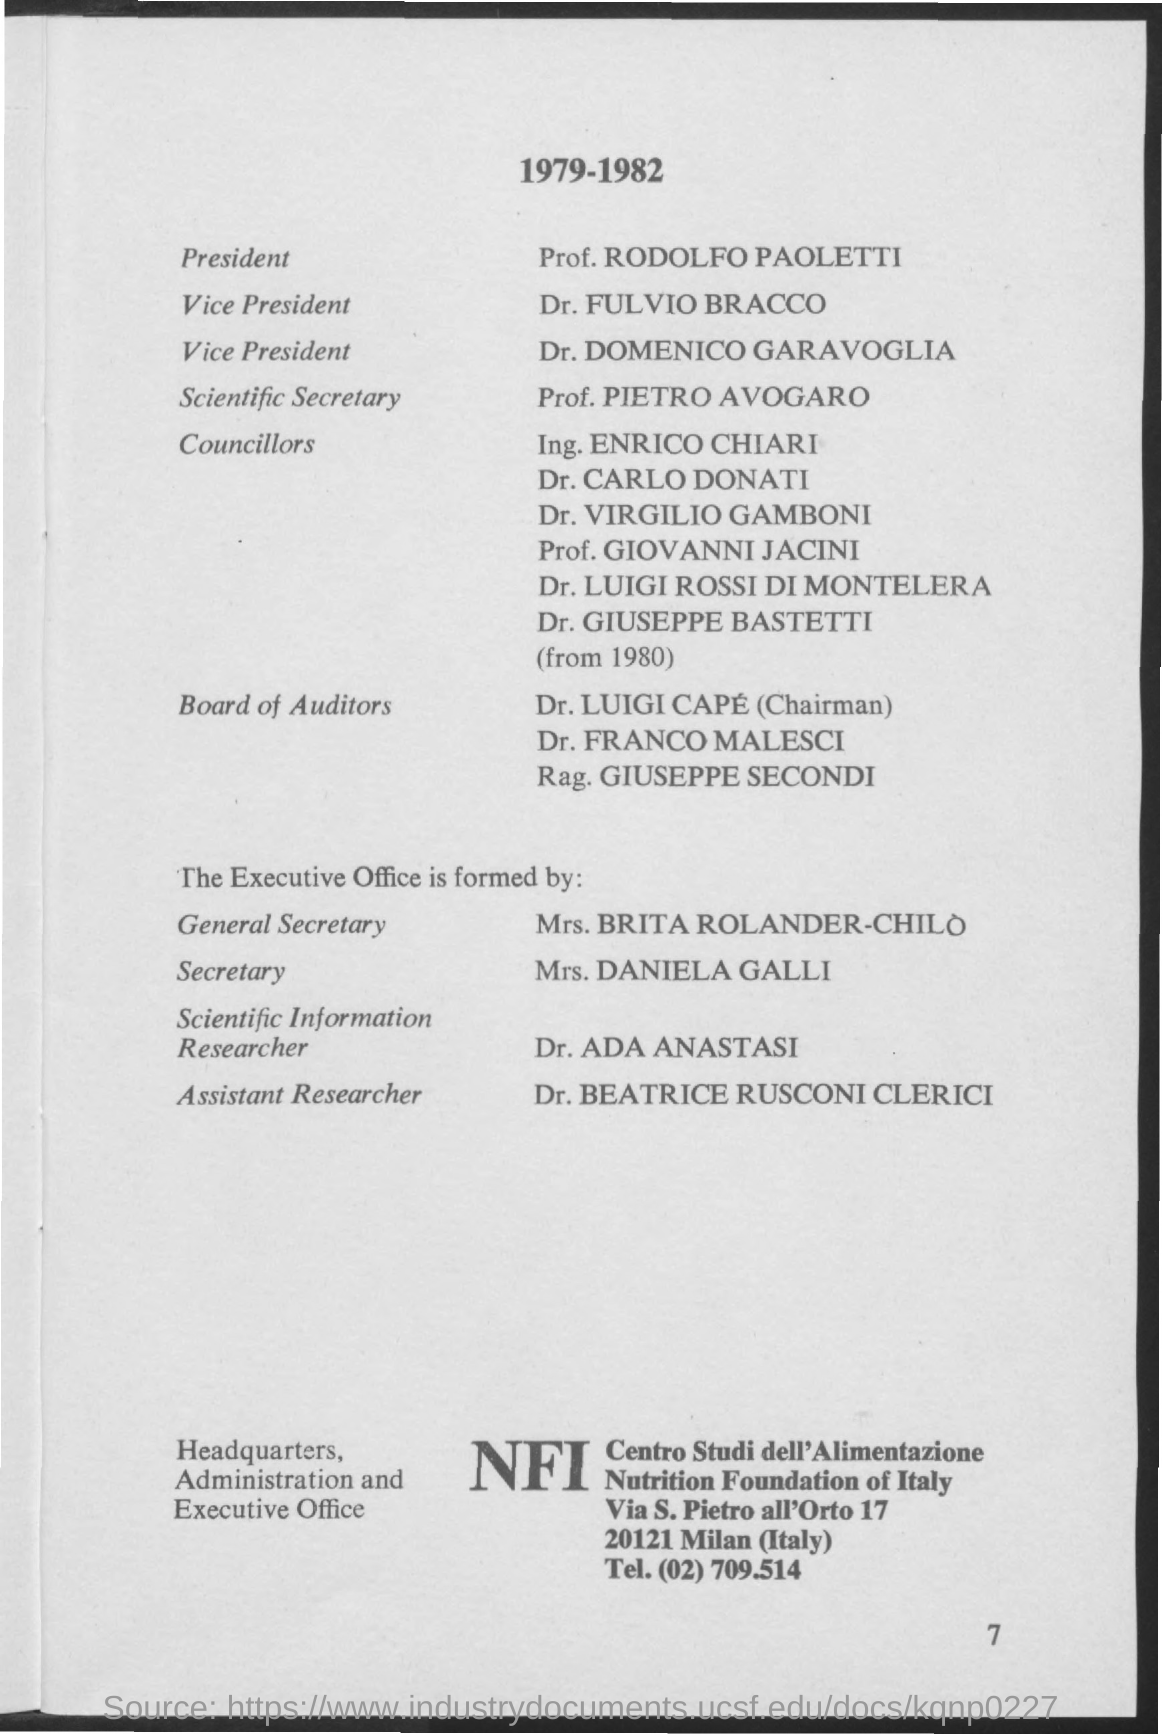Highlight a few significant elements in this photo. Mrs. Daniela Galli is the Secretary. The President is Prof. RODOLFO PAOLETTI. The Scientific Secretary is Professor Pietro Avogaro. 